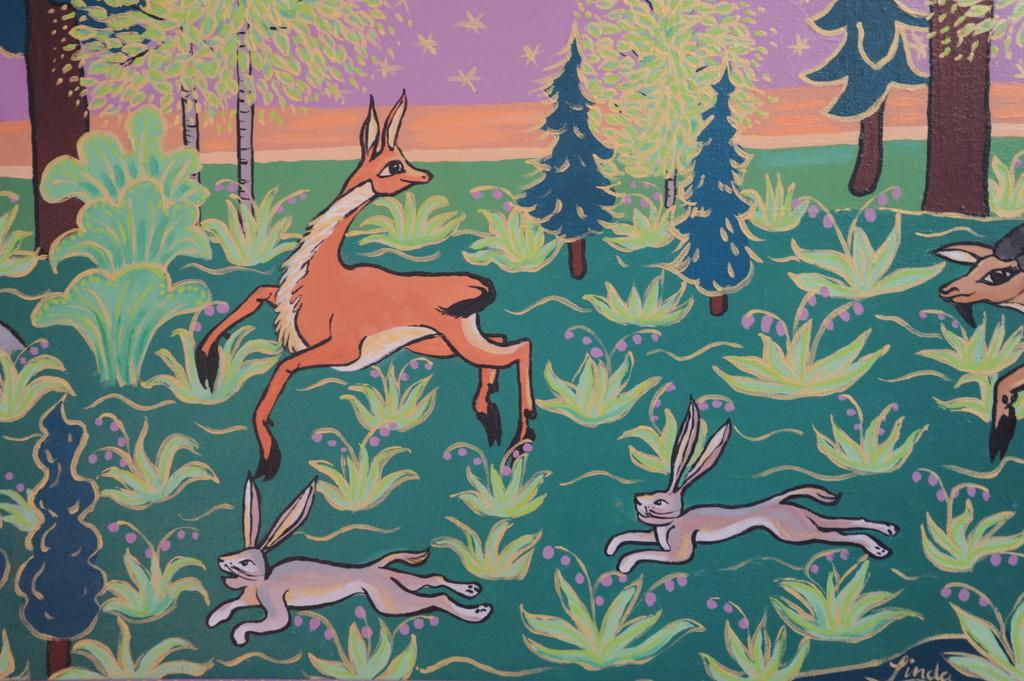What is the main subject of the image? There is a picture in the image. What is happening in the picture? The picture contains animals running. What type of landscape is depicted in the picture? There are trees in the picture. How does the picture start in the image? The picture does not start in the image; it is already present and visible. 